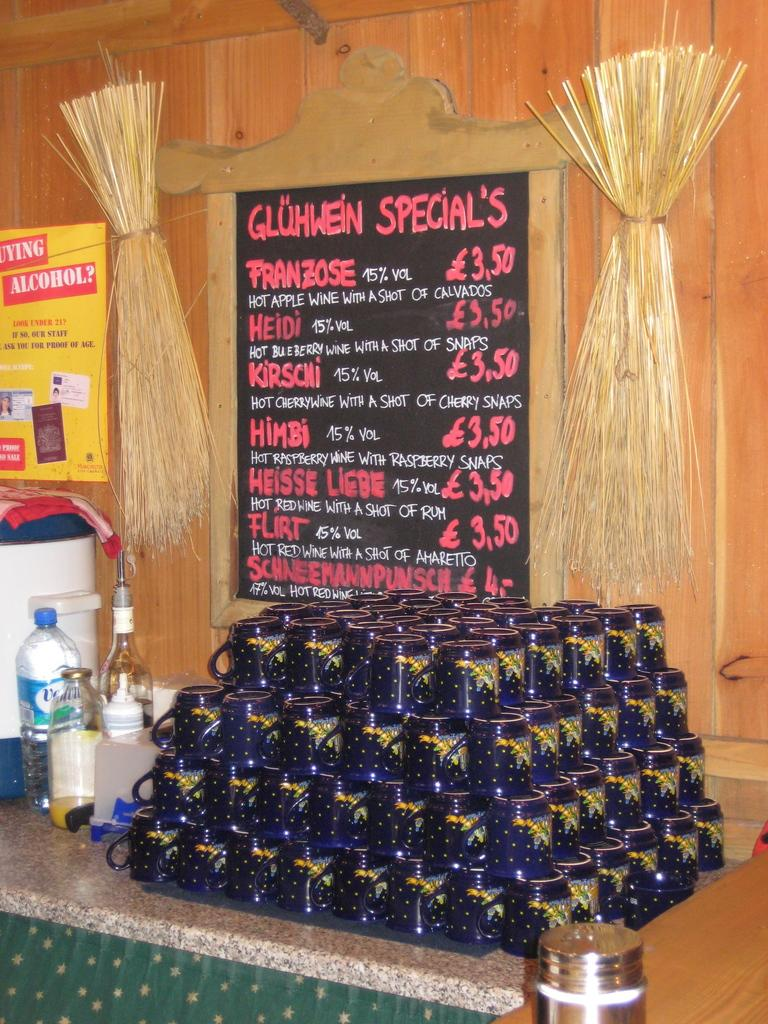<image>
Give a short and clear explanation of the subsequent image. A stack of blue mugs with yellow stars under a chalkboard advertising Gluhwein specials. 